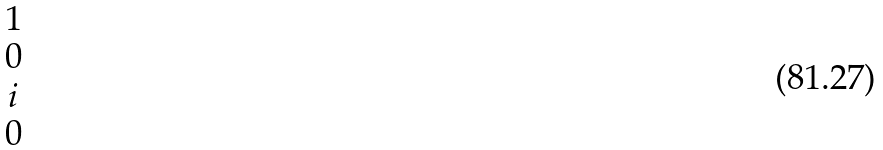Convert formula to latex. <formula><loc_0><loc_0><loc_500><loc_500>\begin{matrix} 1 \\ 0 \\ i \\ 0 \end{matrix}</formula> 